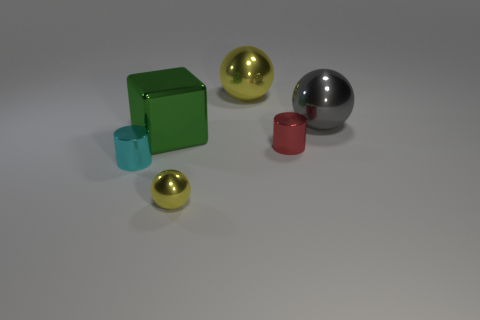Subtract all large shiny balls. How many balls are left? 1 Add 3 large yellow matte cylinders. How many objects exist? 9 Subtract all cylinders. How many objects are left? 4 Subtract 0 purple cubes. How many objects are left? 6 Subtract all large green metal cubes. Subtract all red things. How many objects are left? 4 Add 3 green blocks. How many green blocks are left? 4 Add 6 tiny cyan metallic things. How many tiny cyan metallic things exist? 7 